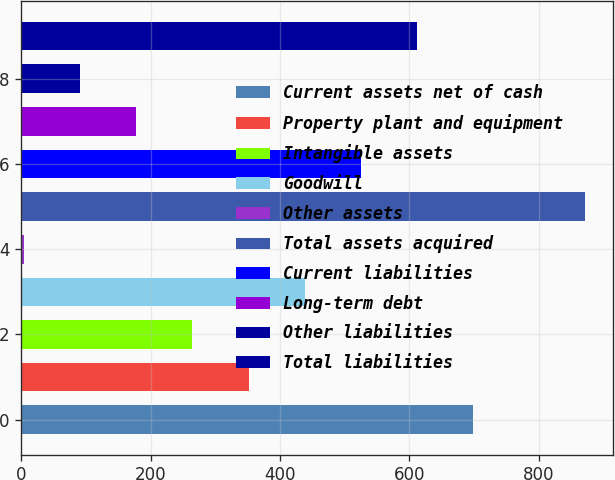<chart> <loc_0><loc_0><loc_500><loc_500><bar_chart><fcel>Current assets net of cash<fcel>Property plant and equipment<fcel>Intangible assets<fcel>Goodwill<fcel>Other assets<fcel>Total assets acquired<fcel>Current liabilities<fcel>Long-term debt<fcel>Other liabilities<fcel>Total liabilities<nl><fcel>697.8<fcel>351.4<fcel>264.8<fcel>438<fcel>5<fcel>871<fcel>524.6<fcel>178.2<fcel>91.6<fcel>611.2<nl></chart> 